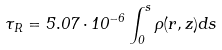Convert formula to latex. <formula><loc_0><loc_0><loc_500><loc_500>\tau _ { R } = 5 . 0 7 \cdot 1 0 ^ { - 6 } \int _ { 0 } ^ { s } \rho ( r , z ) d s</formula> 